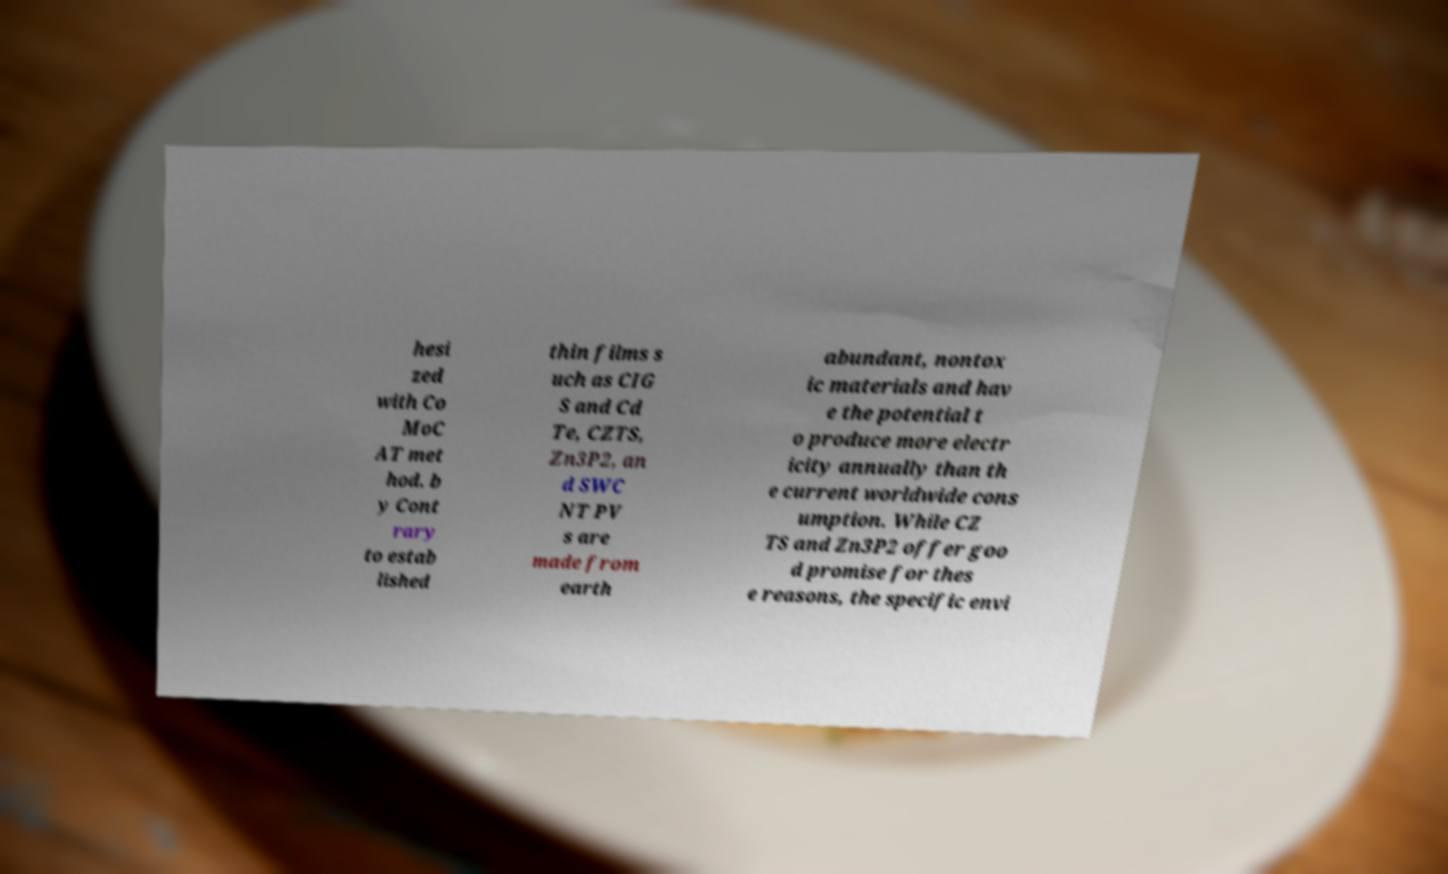There's text embedded in this image that I need extracted. Can you transcribe it verbatim? hesi zed with Co MoC AT met hod. b y Cont rary to estab lished thin films s uch as CIG S and Cd Te, CZTS, Zn3P2, an d SWC NT PV s are made from earth abundant, nontox ic materials and hav e the potential t o produce more electr icity annually than th e current worldwide cons umption. While CZ TS and Zn3P2 offer goo d promise for thes e reasons, the specific envi 